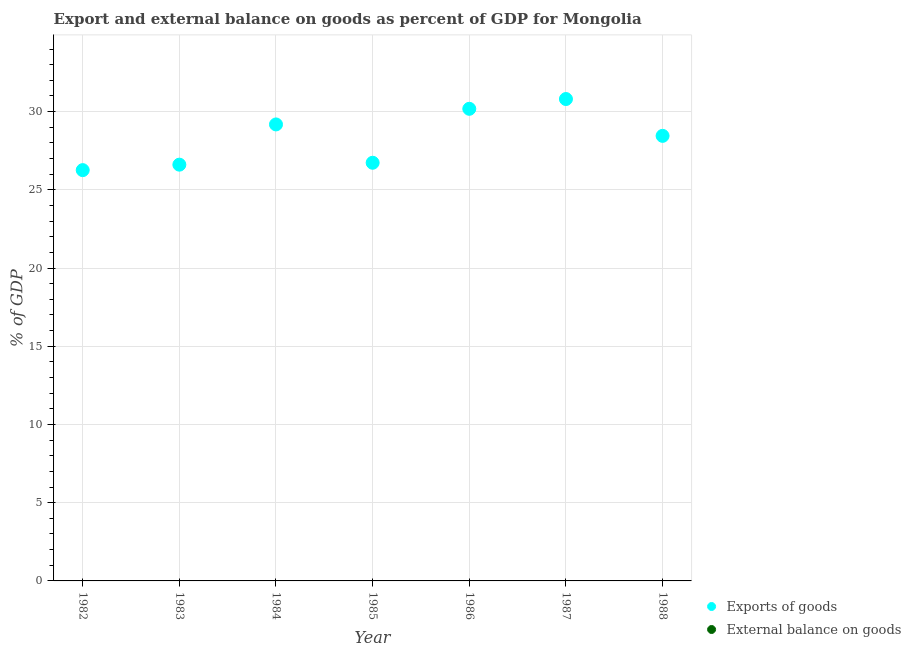How many different coloured dotlines are there?
Ensure brevity in your answer.  1. Across all years, what is the maximum export of goods as percentage of gdp?
Provide a short and direct response. 30.8. Across all years, what is the minimum export of goods as percentage of gdp?
Your response must be concise. 26.26. In which year was the export of goods as percentage of gdp maximum?
Offer a very short reply. 1987. What is the total external balance on goods as percentage of gdp in the graph?
Make the answer very short. 0. What is the difference between the export of goods as percentage of gdp in 1986 and that in 1988?
Provide a succinct answer. 1.73. What is the difference between the export of goods as percentage of gdp in 1986 and the external balance on goods as percentage of gdp in 1984?
Provide a succinct answer. 30.18. In how many years, is the external balance on goods as percentage of gdp greater than 13 %?
Your response must be concise. 0. What is the ratio of the export of goods as percentage of gdp in 1985 to that in 1988?
Keep it short and to the point. 0.94. Is the export of goods as percentage of gdp in 1984 less than that in 1986?
Your answer should be very brief. Yes. What is the difference between the highest and the lowest export of goods as percentage of gdp?
Ensure brevity in your answer.  4.54. In how many years, is the external balance on goods as percentage of gdp greater than the average external balance on goods as percentage of gdp taken over all years?
Make the answer very short. 0. Does the export of goods as percentage of gdp monotonically increase over the years?
Provide a succinct answer. No. How many dotlines are there?
Your answer should be very brief. 1. Are the values on the major ticks of Y-axis written in scientific E-notation?
Offer a terse response. No. Does the graph contain any zero values?
Ensure brevity in your answer.  Yes. Where does the legend appear in the graph?
Your response must be concise. Bottom right. How many legend labels are there?
Make the answer very short. 2. How are the legend labels stacked?
Your answer should be compact. Vertical. What is the title of the graph?
Your answer should be compact. Export and external balance on goods as percent of GDP for Mongolia. Does "Private creditors" appear as one of the legend labels in the graph?
Provide a succinct answer. No. What is the label or title of the X-axis?
Your answer should be compact. Year. What is the label or title of the Y-axis?
Your answer should be compact. % of GDP. What is the % of GDP in Exports of goods in 1982?
Give a very brief answer. 26.26. What is the % of GDP in External balance on goods in 1982?
Keep it short and to the point. 0. What is the % of GDP in Exports of goods in 1983?
Make the answer very short. 26.61. What is the % of GDP of External balance on goods in 1983?
Your response must be concise. 0. What is the % of GDP of Exports of goods in 1984?
Provide a short and direct response. 29.18. What is the % of GDP of Exports of goods in 1985?
Provide a succinct answer. 26.73. What is the % of GDP in External balance on goods in 1985?
Your answer should be compact. 0. What is the % of GDP of Exports of goods in 1986?
Provide a short and direct response. 30.18. What is the % of GDP in External balance on goods in 1986?
Offer a terse response. 0. What is the % of GDP of Exports of goods in 1987?
Keep it short and to the point. 30.8. What is the % of GDP of External balance on goods in 1987?
Your answer should be compact. 0. What is the % of GDP in Exports of goods in 1988?
Offer a very short reply. 28.45. What is the % of GDP in External balance on goods in 1988?
Your answer should be very brief. 0. Across all years, what is the maximum % of GDP of Exports of goods?
Offer a terse response. 30.8. Across all years, what is the minimum % of GDP of Exports of goods?
Give a very brief answer. 26.26. What is the total % of GDP in Exports of goods in the graph?
Provide a succinct answer. 198.21. What is the difference between the % of GDP in Exports of goods in 1982 and that in 1983?
Offer a very short reply. -0.35. What is the difference between the % of GDP in Exports of goods in 1982 and that in 1984?
Your response must be concise. -2.92. What is the difference between the % of GDP in Exports of goods in 1982 and that in 1985?
Offer a very short reply. -0.47. What is the difference between the % of GDP of Exports of goods in 1982 and that in 1986?
Give a very brief answer. -3.92. What is the difference between the % of GDP of Exports of goods in 1982 and that in 1987?
Provide a succinct answer. -4.54. What is the difference between the % of GDP of Exports of goods in 1982 and that in 1988?
Give a very brief answer. -2.19. What is the difference between the % of GDP of Exports of goods in 1983 and that in 1984?
Offer a very short reply. -2.57. What is the difference between the % of GDP in Exports of goods in 1983 and that in 1985?
Offer a very short reply. -0.12. What is the difference between the % of GDP in Exports of goods in 1983 and that in 1986?
Provide a succinct answer. -3.57. What is the difference between the % of GDP in Exports of goods in 1983 and that in 1987?
Make the answer very short. -4.2. What is the difference between the % of GDP of Exports of goods in 1983 and that in 1988?
Your answer should be compact. -1.84. What is the difference between the % of GDP of Exports of goods in 1984 and that in 1985?
Your answer should be compact. 2.45. What is the difference between the % of GDP of Exports of goods in 1984 and that in 1986?
Offer a very short reply. -1. What is the difference between the % of GDP in Exports of goods in 1984 and that in 1987?
Keep it short and to the point. -1.62. What is the difference between the % of GDP in Exports of goods in 1984 and that in 1988?
Provide a succinct answer. 0.73. What is the difference between the % of GDP of Exports of goods in 1985 and that in 1986?
Give a very brief answer. -3.45. What is the difference between the % of GDP of Exports of goods in 1985 and that in 1987?
Keep it short and to the point. -4.07. What is the difference between the % of GDP of Exports of goods in 1985 and that in 1988?
Keep it short and to the point. -1.72. What is the difference between the % of GDP of Exports of goods in 1986 and that in 1987?
Give a very brief answer. -0.63. What is the difference between the % of GDP in Exports of goods in 1986 and that in 1988?
Provide a short and direct response. 1.73. What is the difference between the % of GDP of Exports of goods in 1987 and that in 1988?
Make the answer very short. 2.35. What is the average % of GDP in Exports of goods per year?
Provide a succinct answer. 28.32. What is the ratio of the % of GDP in Exports of goods in 1982 to that in 1983?
Offer a very short reply. 0.99. What is the ratio of the % of GDP in Exports of goods in 1982 to that in 1984?
Your answer should be compact. 0.9. What is the ratio of the % of GDP of Exports of goods in 1982 to that in 1985?
Provide a short and direct response. 0.98. What is the ratio of the % of GDP of Exports of goods in 1982 to that in 1986?
Offer a very short reply. 0.87. What is the ratio of the % of GDP in Exports of goods in 1982 to that in 1987?
Offer a terse response. 0.85. What is the ratio of the % of GDP in Exports of goods in 1982 to that in 1988?
Keep it short and to the point. 0.92. What is the ratio of the % of GDP of Exports of goods in 1983 to that in 1984?
Make the answer very short. 0.91. What is the ratio of the % of GDP of Exports of goods in 1983 to that in 1985?
Your answer should be very brief. 1. What is the ratio of the % of GDP in Exports of goods in 1983 to that in 1986?
Provide a short and direct response. 0.88. What is the ratio of the % of GDP of Exports of goods in 1983 to that in 1987?
Ensure brevity in your answer.  0.86. What is the ratio of the % of GDP in Exports of goods in 1983 to that in 1988?
Your response must be concise. 0.94. What is the ratio of the % of GDP of Exports of goods in 1984 to that in 1985?
Ensure brevity in your answer.  1.09. What is the ratio of the % of GDP of Exports of goods in 1984 to that in 1986?
Your response must be concise. 0.97. What is the ratio of the % of GDP in Exports of goods in 1984 to that in 1987?
Keep it short and to the point. 0.95. What is the ratio of the % of GDP in Exports of goods in 1984 to that in 1988?
Your response must be concise. 1.03. What is the ratio of the % of GDP in Exports of goods in 1985 to that in 1986?
Your response must be concise. 0.89. What is the ratio of the % of GDP in Exports of goods in 1985 to that in 1987?
Offer a terse response. 0.87. What is the ratio of the % of GDP of Exports of goods in 1985 to that in 1988?
Give a very brief answer. 0.94. What is the ratio of the % of GDP in Exports of goods in 1986 to that in 1987?
Offer a terse response. 0.98. What is the ratio of the % of GDP of Exports of goods in 1986 to that in 1988?
Your answer should be very brief. 1.06. What is the ratio of the % of GDP in Exports of goods in 1987 to that in 1988?
Make the answer very short. 1.08. What is the difference between the highest and the second highest % of GDP of Exports of goods?
Keep it short and to the point. 0.63. What is the difference between the highest and the lowest % of GDP in Exports of goods?
Your response must be concise. 4.54. 